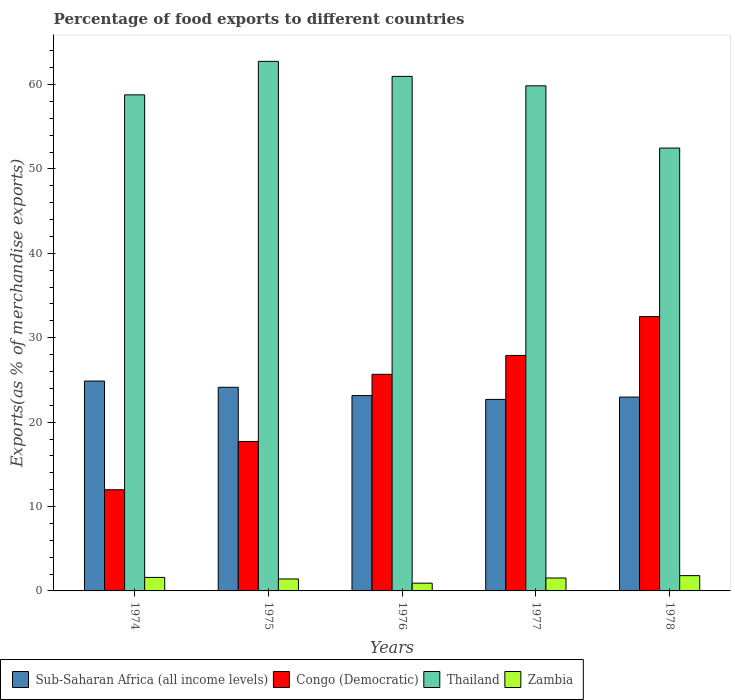How many different coloured bars are there?
Offer a terse response. 4. Are the number of bars per tick equal to the number of legend labels?
Your response must be concise. Yes. Are the number of bars on each tick of the X-axis equal?
Ensure brevity in your answer.  Yes. How many bars are there on the 4th tick from the left?
Keep it short and to the point. 4. How many bars are there on the 1st tick from the right?
Offer a very short reply. 4. In how many cases, is the number of bars for a given year not equal to the number of legend labels?
Ensure brevity in your answer.  0. What is the percentage of exports to different countries in Thailand in 1978?
Your answer should be compact. 52.47. Across all years, what is the maximum percentage of exports to different countries in Zambia?
Ensure brevity in your answer.  1.81. Across all years, what is the minimum percentage of exports to different countries in Thailand?
Ensure brevity in your answer.  52.47. In which year was the percentage of exports to different countries in Congo (Democratic) maximum?
Offer a very short reply. 1978. In which year was the percentage of exports to different countries in Sub-Saharan Africa (all income levels) minimum?
Give a very brief answer. 1977. What is the total percentage of exports to different countries in Thailand in the graph?
Provide a short and direct response. 294.83. What is the difference between the percentage of exports to different countries in Sub-Saharan Africa (all income levels) in 1976 and that in 1978?
Provide a short and direct response. 0.18. What is the difference between the percentage of exports to different countries in Sub-Saharan Africa (all income levels) in 1975 and the percentage of exports to different countries in Congo (Democratic) in 1978?
Offer a terse response. -8.38. What is the average percentage of exports to different countries in Zambia per year?
Your response must be concise. 1.46. In the year 1975, what is the difference between the percentage of exports to different countries in Sub-Saharan Africa (all income levels) and percentage of exports to different countries in Congo (Democratic)?
Give a very brief answer. 6.42. In how many years, is the percentage of exports to different countries in Sub-Saharan Africa (all income levels) greater than 48 %?
Your answer should be compact. 0. What is the ratio of the percentage of exports to different countries in Thailand in 1974 to that in 1976?
Your answer should be very brief. 0.96. Is the difference between the percentage of exports to different countries in Sub-Saharan Africa (all income levels) in 1977 and 1978 greater than the difference between the percentage of exports to different countries in Congo (Democratic) in 1977 and 1978?
Offer a terse response. Yes. What is the difference between the highest and the second highest percentage of exports to different countries in Congo (Democratic)?
Provide a short and direct response. 4.61. What is the difference between the highest and the lowest percentage of exports to different countries in Congo (Democratic)?
Offer a terse response. 20.52. Is the sum of the percentage of exports to different countries in Zambia in 1976 and 1978 greater than the maximum percentage of exports to different countries in Sub-Saharan Africa (all income levels) across all years?
Your answer should be compact. No. Is it the case that in every year, the sum of the percentage of exports to different countries in Zambia and percentage of exports to different countries in Thailand is greater than the sum of percentage of exports to different countries in Congo (Democratic) and percentage of exports to different countries in Sub-Saharan Africa (all income levels)?
Provide a succinct answer. No. What does the 3rd bar from the left in 1975 represents?
Your response must be concise. Thailand. What does the 3rd bar from the right in 1975 represents?
Provide a short and direct response. Congo (Democratic). Is it the case that in every year, the sum of the percentage of exports to different countries in Congo (Democratic) and percentage of exports to different countries in Zambia is greater than the percentage of exports to different countries in Sub-Saharan Africa (all income levels)?
Provide a succinct answer. No. How many years are there in the graph?
Give a very brief answer. 5. Are the values on the major ticks of Y-axis written in scientific E-notation?
Provide a succinct answer. No. How many legend labels are there?
Ensure brevity in your answer.  4. How are the legend labels stacked?
Offer a terse response. Horizontal. What is the title of the graph?
Ensure brevity in your answer.  Percentage of food exports to different countries. What is the label or title of the Y-axis?
Your answer should be compact. Exports(as % of merchandise exports). What is the Exports(as % of merchandise exports) in Sub-Saharan Africa (all income levels) in 1974?
Offer a very short reply. 24.87. What is the Exports(as % of merchandise exports) in Congo (Democratic) in 1974?
Offer a very short reply. 11.99. What is the Exports(as % of merchandise exports) in Thailand in 1974?
Provide a short and direct response. 58.78. What is the Exports(as % of merchandise exports) in Zambia in 1974?
Your answer should be very brief. 1.6. What is the Exports(as % of merchandise exports) in Sub-Saharan Africa (all income levels) in 1975?
Give a very brief answer. 24.13. What is the Exports(as % of merchandise exports) in Congo (Democratic) in 1975?
Keep it short and to the point. 17.71. What is the Exports(as % of merchandise exports) in Thailand in 1975?
Ensure brevity in your answer.  62.75. What is the Exports(as % of merchandise exports) in Zambia in 1975?
Give a very brief answer. 1.42. What is the Exports(as % of merchandise exports) of Sub-Saharan Africa (all income levels) in 1976?
Your response must be concise. 23.15. What is the Exports(as % of merchandise exports) of Congo (Democratic) in 1976?
Provide a succinct answer. 25.67. What is the Exports(as % of merchandise exports) in Thailand in 1976?
Offer a very short reply. 60.97. What is the Exports(as % of merchandise exports) in Zambia in 1976?
Your answer should be compact. 0.92. What is the Exports(as % of merchandise exports) of Sub-Saharan Africa (all income levels) in 1977?
Your response must be concise. 22.7. What is the Exports(as % of merchandise exports) in Congo (Democratic) in 1977?
Offer a terse response. 27.9. What is the Exports(as % of merchandise exports) of Thailand in 1977?
Provide a short and direct response. 59.85. What is the Exports(as % of merchandise exports) of Zambia in 1977?
Provide a succinct answer. 1.53. What is the Exports(as % of merchandise exports) in Sub-Saharan Africa (all income levels) in 1978?
Provide a short and direct response. 22.97. What is the Exports(as % of merchandise exports) of Congo (Democratic) in 1978?
Make the answer very short. 32.51. What is the Exports(as % of merchandise exports) of Thailand in 1978?
Offer a very short reply. 52.47. What is the Exports(as % of merchandise exports) of Zambia in 1978?
Provide a succinct answer. 1.81. Across all years, what is the maximum Exports(as % of merchandise exports) in Sub-Saharan Africa (all income levels)?
Offer a very short reply. 24.87. Across all years, what is the maximum Exports(as % of merchandise exports) of Congo (Democratic)?
Provide a succinct answer. 32.51. Across all years, what is the maximum Exports(as % of merchandise exports) in Thailand?
Offer a terse response. 62.75. Across all years, what is the maximum Exports(as % of merchandise exports) of Zambia?
Your answer should be compact. 1.81. Across all years, what is the minimum Exports(as % of merchandise exports) of Sub-Saharan Africa (all income levels)?
Offer a terse response. 22.7. Across all years, what is the minimum Exports(as % of merchandise exports) in Congo (Democratic)?
Give a very brief answer. 11.99. Across all years, what is the minimum Exports(as % of merchandise exports) of Thailand?
Provide a succinct answer. 52.47. Across all years, what is the minimum Exports(as % of merchandise exports) in Zambia?
Your response must be concise. 0.92. What is the total Exports(as % of merchandise exports) in Sub-Saharan Africa (all income levels) in the graph?
Offer a very short reply. 117.81. What is the total Exports(as % of merchandise exports) in Congo (Democratic) in the graph?
Your answer should be very brief. 115.77. What is the total Exports(as % of merchandise exports) of Thailand in the graph?
Offer a terse response. 294.83. What is the total Exports(as % of merchandise exports) in Zambia in the graph?
Your response must be concise. 7.28. What is the difference between the Exports(as % of merchandise exports) of Sub-Saharan Africa (all income levels) in 1974 and that in 1975?
Offer a terse response. 0.74. What is the difference between the Exports(as % of merchandise exports) in Congo (Democratic) in 1974 and that in 1975?
Offer a very short reply. -5.72. What is the difference between the Exports(as % of merchandise exports) in Thailand in 1974 and that in 1975?
Provide a short and direct response. -3.97. What is the difference between the Exports(as % of merchandise exports) of Zambia in 1974 and that in 1975?
Keep it short and to the point. 0.18. What is the difference between the Exports(as % of merchandise exports) in Sub-Saharan Africa (all income levels) in 1974 and that in 1976?
Provide a short and direct response. 1.72. What is the difference between the Exports(as % of merchandise exports) in Congo (Democratic) in 1974 and that in 1976?
Provide a succinct answer. -13.68. What is the difference between the Exports(as % of merchandise exports) in Thailand in 1974 and that in 1976?
Ensure brevity in your answer.  -2.19. What is the difference between the Exports(as % of merchandise exports) in Zambia in 1974 and that in 1976?
Provide a succinct answer. 0.68. What is the difference between the Exports(as % of merchandise exports) in Sub-Saharan Africa (all income levels) in 1974 and that in 1977?
Make the answer very short. 2.17. What is the difference between the Exports(as % of merchandise exports) of Congo (Democratic) in 1974 and that in 1977?
Provide a succinct answer. -15.91. What is the difference between the Exports(as % of merchandise exports) of Thailand in 1974 and that in 1977?
Your answer should be very brief. -1.07. What is the difference between the Exports(as % of merchandise exports) of Zambia in 1974 and that in 1977?
Keep it short and to the point. 0.07. What is the difference between the Exports(as % of merchandise exports) of Sub-Saharan Africa (all income levels) in 1974 and that in 1978?
Offer a very short reply. 1.9. What is the difference between the Exports(as % of merchandise exports) of Congo (Democratic) in 1974 and that in 1978?
Offer a very short reply. -20.52. What is the difference between the Exports(as % of merchandise exports) of Thailand in 1974 and that in 1978?
Make the answer very short. 6.31. What is the difference between the Exports(as % of merchandise exports) of Zambia in 1974 and that in 1978?
Offer a very short reply. -0.21. What is the difference between the Exports(as % of merchandise exports) of Sub-Saharan Africa (all income levels) in 1975 and that in 1976?
Your answer should be compact. 0.98. What is the difference between the Exports(as % of merchandise exports) in Congo (Democratic) in 1975 and that in 1976?
Provide a short and direct response. -7.96. What is the difference between the Exports(as % of merchandise exports) of Thailand in 1975 and that in 1976?
Your answer should be very brief. 1.78. What is the difference between the Exports(as % of merchandise exports) in Zambia in 1975 and that in 1976?
Give a very brief answer. 0.5. What is the difference between the Exports(as % of merchandise exports) of Sub-Saharan Africa (all income levels) in 1975 and that in 1977?
Provide a short and direct response. 1.43. What is the difference between the Exports(as % of merchandise exports) of Congo (Democratic) in 1975 and that in 1977?
Your answer should be very brief. -10.19. What is the difference between the Exports(as % of merchandise exports) in Thailand in 1975 and that in 1977?
Your answer should be compact. 2.9. What is the difference between the Exports(as % of merchandise exports) of Zambia in 1975 and that in 1977?
Keep it short and to the point. -0.11. What is the difference between the Exports(as % of merchandise exports) in Sub-Saharan Africa (all income levels) in 1975 and that in 1978?
Make the answer very short. 1.16. What is the difference between the Exports(as % of merchandise exports) in Congo (Democratic) in 1975 and that in 1978?
Ensure brevity in your answer.  -14.8. What is the difference between the Exports(as % of merchandise exports) of Thailand in 1975 and that in 1978?
Keep it short and to the point. 10.28. What is the difference between the Exports(as % of merchandise exports) of Zambia in 1975 and that in 1978?
Make the answer very short. -0.39. What is the difference between the Exports(as % of merchandise exports) of Sub-Saharan Africa (all income levels) in 1976 and that in 1977?
Your answer should be very brief. 0.45. What is the difference between the Exports(as % of merchandise exports) of Congo (Democratic) in 1976 and that in 1977?
Keep it short and to the point. -2.24. What is the difference between the Exports(as % of merchandise exports) in Thailand in 1976 and that in 1977?
Make the answer very short. 1.12. What is the difference between the Exports(as % of merchandise exports) of Zambia in 1976 and that in 1977?
Offer a terse response. -0.61. What is the difference between the Exports(as % of merchandise exports) of Sub-Saharan Africa (all income levels) in 1976 and that in 1978?
Make the answer very short. 0.18. What is the difference between the Exports(as % of merchandise exports) in Congo (Democratic) in 1976 and that in 1978?
Provide a succinct answer. -6.84. What is the difference between the Exports(as % of merchandise exports) of Thailand in 1976 and that in 1978?
Ensure brevity in your answer.  8.49. What is the difference between the Exports(as % of merchandise exports) of Zambia in 1976 and that in 1978?
Provide a succinct answer. -0.89. What is the difference between the Exports(as % of merchandise exports) in Sub-Saharan Africa (all income levels) in 1977 and that in 1978?
Make the answer very short. -0.27. What is the difference between the Exports(as % of merchandise exports) in Congo (Democratic) in 1977 and that in 1978?
Ensure brevity in your answer.  -4.61. What is the difference between the Exports(as % of merchandise exports) of Thailand in 1977 and that in 1978?
Keep it short and to the point. 7.38. What is the difference between the Exports(as % of merchandise exports) of Zambia in 1977 and that in 1978?
Keep it short and to the point. -0.28. What is the difference between the Exports(as % of merchandise exports) in Sub-Saharan Africa (all income levels) in 1974 and the Exports(as % of merchandise exports) in Congo (Democratic) in 1975?
Your answer should be very brief. 7.16. What is the difference between the Exports(as % of merchandise exports) in Sub-Saharan Africa (all income levels) in 1974 and the Exports(as % of merchandise exports) in Thailand in 1975?
Offer a terse response. -37.88. What is the difference between the Exports(as % of merchandise exports) in Sub-Saharan Africa (all income levels) in 1974 and the Exports(as % of merchandise exports) in Zambia in 1975?
Offer a very short reply. 23.45. What is the difference between the Exports(as % of merchandise exports) in Congo (Democratic) in 1974 and the Exports(as % of merchandise exports) in Thailand in 1975?
Offer a very short reply. -50.76. What is the difference between the Exports(as % of merchandise exports) of Congo (Democratic) in 1974 and the Exports(as % of merchandise exports) of Zambia in 1975?
Make the answer very short. 10.57. What is the difference between the Exports(as % of merchandise exports) in Thailand in 1974 and the Exports(as % of merchandise exports) in Zambia in 1975?
Ensure brevity in your answer.  57.36. What is the difference between the Exports(as % of merchandise exports) of Sub-Saharan Africa (all income levels) in 1974 and the Exports(as % of merchandise exports) of Congo (Democratic) in 1976?
Offer a very short reply. -0.8. What is the difference between the Exports(as % of merchandise exports) in Sub-Saharan Africa (all income levels) in 1974 and the Exports(as % of merchandise exports) in Thailand in 1976?
Keep it short and to the point. -36.1. What is the difference between the Exports(as % of merchandise exports) in Sub-Saharan Africa (all income levels) in 1974 and the Exports(as % of merchandise exports) in Zambia in 1976?
Offer a terse response. 23.95. What is the difference between the Exports(as % of merchandise exports) of Congo (Democratic) in 1974 and the Exports(as % of merchandise exports) of Thailand in 1976?
Provide a short and direct response. -48.98. What is the difference between the Exports(as % of merchandise exports) of Congo (Democratic) in 1974 and the Exports(as % of merchandise exports) of Zambia in 1976?
Your answer should be compact. 11.07. What is the difference between the Exports(as % of merchandise exports) in Thailand in 1974 and the Exports(as % of merchandise exports) in Zambia in 1976?
Ensure brevity in your answer.  57.86. What is the difference between the Exports(as % of merchandise exports) of Sub-Saharan Africa (all income levels) in 1974 and the Exports(as % of merchandise exports) of Congo (Democratic) in 1977?
Your answer should be compact. -3.03. What is the difference between the Exports(as % of merchandise exports) in Sub-Saharan Africa (all income levels) in 1974 and the Exports(as % of merchandise exports) in Thailand in 1977?
Give a very brief answer. -34.98. What is the difference between the Exports(as % of merchandise exports) in Sub-Saharan Africa (all income levels) in 1974 and the Exports(as % of merchandise exports) in Zambia in 1977?
Provide a short and direct response. 23.34. What is the difference between the Exports(as % of merchandise exports) in Congo (Democratic) in 1974 and the Exports(as % of merchandise exports) in Thailand in 1977?
Provide a short and direct response. -47.86. What is the difference between the Exports(as % of merchandise exports) of Congo (Democratic) in 1974 and the Exports(as % of merchandise exports) of Zambia in 1977?
Give a very brief answer. 10.46. What is the difference between the Exports(as % of merchandise exports) in Thailand in 1974 and the Exports(as % of merchandise exports) in Zambia in 1977?
Make the answer very short. 57.25. What is the difference between the Exports(as % of merchandise exports) of Sub-Saharan Africa (all income levels) in 1974 and the Exports(as % of merchandise exports) of Congo (Democratic) in 1978?
Offer a terse response. -7.64. What is the difference between the Exports(as % of merchandise exports) in Sub-Saharan Africa (all income levels) in 1974 and the Exports(as % of merchandise exports) in Thailand in 1978?
Your response must be concise. -27.61. What is the difference between the Exports(as % of merchandise exports) in Sub-Saharan Africa (all income levels) in 1974 and the Exports(as % of merchandise exports) in Zambia in 1978?
Offer a very short reply. 23.06. What is the difference between the Exports(as % of merchandise exports) in Congo (Democratic) in 1974 and the Exports(as % of merchandise exports) in Thailand in 1978?
Provide a succinct answer. -40.49. What is the difference between the Exports(as % of merchandise exports) in Congo (Democratic) in 1974 and the Exports(as % of merchandise exports) in Zambia in 1978?
Give a very brief answer. 10.18. What is the difference between the Exports(as % of merchandise exports) in Thailand in 1974 and the Exports(as % of merchandise exports) in Zambia in 1978?
Your response must be concise. 56.97. What is the difference between the Exports(as % of merchandise exports) in Sub-Saharan Africa (all income levels) in 1975 and the Exports(as % of merchandise exports) in Congo (Democratic) in 1976?
Make the answer very short. -1.54. What is the difference between the Exports(as % of merchandise exports) of Sub-Saharan Africa (all income levels) in 1975 and the Exports(as % of merchandise exports) of Thailand in 1976?
Provide a short and direct response. -36.84. What is the difference between the Exports(as % of merchandise exports) in Sub-Saharan Africa (all income levels) in 1975 and the Exports(as % of merchandise exports) in Zambia in 1976?
Your answer should be compact. 23.21. What is the difference between the Exports(as % of merchandise exports) in Congo (Democratic) in 1975 and the Exports(as % of merchandise exports) in Thailand in 1976?
Give a very brief answer. -43.26. What is the difference between the Exports(as % of merchandise exports) in Congo (Democratic) in 1975 and the Exports(as % of merchandise exports) in Zambia in 1976?
Your response must be concise. 16.79. What is the difference between the Exports(as % of merchandise exports) of Thailand in 1975 and the Exports(as % of merchandise exports) of Zambia in 1976?
Provide a short and direct response. 61.83. What is the difference between the Exports(as % of merchandise exports) in Sub-Saharan Africa (all income levels) in 1975 and the Exports(as % of merchandise exports) in Congo (Democratic) in 1977?
Offer a terse response. -3.77. What is the difference between the Exports(as % of merchandise exports) of Sub-Saharan Africa (all income levels) in 1975 and the Exports(as % of merchandise exports) of Thailand in 1977?
Make the answer very short. -35.72. What is the difference between the Exports(as % of merchandise exports) of Sub-Saharan Africa (all income levels) in 1975 and the Exports(as % of merchandise exports) of Zambia in 1977?
Provide a short and direct response. 22.6. What is the difference between the Exports(as % of merchandise exports) in Congo (Democratic) in 1975 and the Exports(as % of merchandise exports) in Thailand in 1977?
Offer a very short reply. -42.14. What is the difference between the Exports(as % of merchandise exports) of Congo (Democratic) in 1975 and the Exports(as % of merchandise exports) of Zambia in 1977?
Your answer should be very brief. 16.18. What is the difference between the Exports(as % of merchandise exports) of Thailand in 1975 and the Exports(as % of merchandise exports) of Zambia in 1977?
Make the answer very short. 61.22. What is the difference between the Exports(as % of merchandise exports) in Sub-Saharan Africa (all income levels) in 1975 and the Exports(as % of merchandise exports) in Congo (Democratic) in 1978?
Provide a short and direct response. -8.38. What is the difference between the Exports(as % of merchandise exports) of Sub-Saharan Africa (all income levels) in 1975 and the Exports(as % of merchandise exports) of Thailand in 1978?
Ensure brevity in your answer.  -28.35. What is the difference between the Exports(as % of merchandise exports) of Sub-Saharan Africa (all income levels) in 1975 and the Exports(as % of merchandise exports) of Zambia in 1978?
Your answer should be compact. 22.32. What is the difference between the Exports(as % of merchandise exports) in Congo (Democratic) in 1975 and the Exports(as % of merchandise exports) in Thailand in 1978?
Keep it short and to the point. -34.77. What is the difference between the Exports(as % of merchandise exports) in Congo (Democratic) in 1975 and the Exports(as % of merchandise exports) in Zambia in 1978?
Your response must be concise. 15.9. What is the difference between the Exports(as % of merchandise exports) in Thailand in 1975 and the Exports(as % of merchandise exports) in Zambia in 1978?
Your response must be concise. 60.94. What is the difference between the Exports(as % of merchandise exports) in Sub-Saharan Africa (all income levels) in 1976 and the Exports(as % of merchandise exports) in Congo (Democratic) in 1977?
Your answer should be very brief. -4.76. What is the difference between the Exports(as % of merchandise exports) in Sub-Saharan Africa (all income levels) in 1976 and the Exports(as % of merchandise exports) in Thailand in 1977?
Your answer should be compact. -36.7. What is the difference between the Exports(as % of merchandise exports) of Sub-Saharan Africa (all income levels) in 1976 and the Exports(as % of merchandise exports) of Zambia in 1977?
Provide a short and direct response. 21.61. What is the difference between the Exports(as % of merchandise exports) in Congo (Democratic) in 1976 and the Exports(as % of merchandise exports) in Thailand in 1977?
Provide a short and direct response. -34.18. What is the difference between the Exports(as % of merchandise exports) in Congo (Democratic) in 1976 and the Exports(as % of merchandise exports) in Zambia in 1977?
Your answer should be compact. 24.14. What is the difference between the Exports(as % of merchandise exports) of Thailand in 1976 and the Exports(as % of merchandise exports) of Zambia in 1977?
Your response must be concise. 59.44. What is the difference between the Exports(as % of merchandise exports) of Sub-Saharan Africa (all income levels) in 1976 and the Exports(as % of merchandise exports) of Congo (Democratic) in 1978?
Ensure brevity in your answer.  -9.36. What is the difference between the Exports(as % of merchandise exports) in Sub-Saharan Africa (all income levels) in 1976 and the Exports(as % of merchandise exports) in Thailand in 1978?
Your answer should be compact. -29.33. What is the difference between the Exports(as % of merchandise exports) in Sub-Saharan Africa (all income levels) in 1976 and the Exports(as % of merchandise exports) in Zambia in 1978?
Offer a very short reply. 21.33. What is the difference between the Exports(as % of merchandise exports) of Congo (Democratic) in 1976 and the Exports(as % of merchandise exports) of Thailand in 1978?
Your answer should be compact. -26.81. What is the difference between the Exports(as % of merchandise exports) of Congo (Democratic) in 1976 and the Exports(as % of merchandise exports) of Zambia in 1978?
Make the answer very short. 23.85. What is the difference between the Exports(as % of merchandise exports) of Thailand in 1976 and the Exports(as % of merchandise exports) of Zambia in 1978?
Provide a succinct answer. 59.16. What is the difference between the Exports(as % of merchandise exports) in Sub-Saharan Africa (all income levels) in 1977 and the Exports(as % of merchandise exports) in Congo (Democratic) in 1978?
Offer a very short reply. -9.81. What is the difference between the Exports(as % of merchandise exports) in Sub-Saharan Africa (all income levels) in 1977 and the Exports(as % of merchandise exports) in Thailand in 1978?
Your answer should be very brief. -29.78. What is the difference between the Exports(as % of merchandise exports) in Sub-Saharan Africa (all income levels) in 1977 and the Exports(as % of merchandise exports) in Zambia in 1978?
Your answer should be very brief. 20.88. What is the difference between the Exports(as % of merchandise exports) of Congo (Democratic) in 1977 and the Exports(as % of merchandise exports) of Thailand in 1978?
Make the answer very short. -24.57. What is the difference between the Exports(as % of merchandise exports) of Congo (Democratic) in 1977 and the Exports(as % of merchandise exports) of Zambia in 1978?
Your answer should be compact. 26.09. What is the difference between the Exports(as % of merchandise exports) of Thailand in 1977 and the Exports(as % of merchandise exports) of Zambia in 1978?
Ensure brevity in your answer.  58.04. What is the average Exports(as % of merchandise exports) in Sub-Saharan Africa (all income levels) per year?
Your response must be concise. 23.56. What is the average Exports(as % of merchandise exports) in Congo (Democratic) per year?
Keep it short and to the point. 23.15. What is the average Exports(as % of merchandise exports) in Thailand per year?
Your answer should be very brief. 58.97. What is the average Exports(as % of merchandise exports) of Zambia per year?
Your response must be concise. 1.46. In the year 1974, what is the difference between the Exports(as % of merchandise exports) in Sub-Saharan Africa (all income levels) and Exports(as % of merchandise exports) in Congo (Democratic)?
Ensure brevity in your answer.  12.88. In the year 1974, what is the difference between the Exports(as % of merchandise exports) in Sub-Saharan Africa (all income levels) and Exports(as % of merchandise exports) in Thailand?
Your answer should be compact. -33.91. In the year 1974, what is the difference between the Exports(as % of merchandise exports) in Sub-Saharan Africa (all income levels) and Exports(as % of merchandise exports) in Zambia?
Your answer should be very brief. 23.27. In the year 1974, what is the difference between the Exports(as % of merchandise exports) in Congo (Democratic) and Exports(as % of merchandise exports) in Thailand?
Provide a succinct answer. -46.79. In the year 1974, what is the difference between the Exports(as % of merchandise exports) in Congo (Democratic) and Exports(as % of merchandise exports) in Zambia?
Your response must be concise. 10.39. In the year 1974, what is the difference between the Exports(as % of merchandise exports) in Thailand and Exports(as % of merchandise exports) in Zambia?
Your response must be concise. 57.18. In the year 1975, what is the difference between the Exports(as % of merchandise exports) of Sub-Saharan Africa (all income levels) and Exports(as % of merchandise exports) of Congo (Democratic)?
Provide a short and direct response. 6.42. In the year 1975, what is the difference between the Exports(as % of merchandise exports) of Sub-Saharan Africa (all income levels) and Exports(as % of merchandise exports) of Thailand?
Make the answer very short. -38.62. In the year 1975, what is the difference between the Exports(as % of merchandise exports) of Sub-Saharan Africa (all income levels) and Exports(as % of merchandise exports) of Zambia?
Make the answer very short. 22.71. In the year 1975, what is the difference between the Exports(as % of merchandise exports) of Congo (Democratic) and Exports(as % of merchandise exports) of Thailand?
Your answer should be very brief. -45.04. In the year 1975, what is the difference between the Exports(as % of merchandise exports) of Congo (Democratic) and Exports(as % of merchandise exports) of Zambia?
Offer a very short reply. 16.29. In the year 1975, what is the difference between the Exports(as % of merchandise exports) in Thailand and Exports(as % of merchandise exports) in Zambia?
Give a very brief answer. 61.33. In the year 1976, what is the difference between the Exports(as % of merchandise exports) in Sub-Saharan Africa (all income levels) and Exports(as % of merchandise exports) in Congo (Democratic)?
Your answer should be very brief. -2.52. In the year 1976, what is the difference between the Exports(as % of merchandise exports) of Sub-Saharan Africa (all income levels) and Exports(as % of merchandise exports) of Thailand?
Provide a short and direct response. -37.82. In the year 1976, what is the difference between the Exports(as % of merchandise exports) of Sub-Saharan Africa (all income levels) and Exports(as % of merchandise exports) of Zambia?
Your answer should be compact. 22.23. In the year 1976, what is the difference between the Exports(as % of merchandise exports) of Congo (Democratic) and Exports(as % of merchandise exports) of Thailand?
Ensure brevity in your answer.  -35.3. In the year 1976, what is the difference between the Exports(as % of merchandise exports) of Congo (Democratic) and Exports(as % of merchandise exports) of Zambia?
Ensure brevity in your answer.  24.75. In the year 1976, what is the difference between the Exports(as % of merchandise exports) of Thailand and Exports(as % of merchandise exports) of Zambia?
Offer a very short reply. 60.05. In the year 1977, what is the difference between the Exports(as % of merchandise exports) in Sub-Saharan Africa (all income levels) and Exports(as % of merchandise exports) in Congo (Democratic)?
Give a very brief answer. -5.21. In the year 1977, what is the difference between the Exports(as % of merchandise exports) in Sub-Saharan Africa (all income levels) and Exports(as % of merchandise exports) in Thailand?
Offer a very short reply. -37.16. In the year 1977, what is the difference between the Exports(as % of merchandise exports) of Sub-Saharan Africa (all income levels) and Exports(as % of merchandise exports) of Zambia?
Keep it short and to the point. 21.16. In the year 1977, what is the difference between the Exports(as % of merchandise exports) in Congo (Democratic) and Exports(as % of merchandise exports) in Thailand?
Your answer should be very brief. -31.95. In the year 1977, what is the difference between the Exports(as % of merchandise exports) of Congo (Democratic) and Exports(as % of merchandise exports) of Zambia?
Provide a short and direct response. 26.37. In the year 1977, what is the difference between the Exports(as % of merchandise exports) in Thailand and Exports(as % of merchandise exports) in Zambia?
Give a very brief answer. 58.32. In the year 1978, what is the difference between the Exports(as % of merchandise exports) of Sub-Saharan Africa (all income levels) and Exports(as % of merchandise exports) of Congo (Democratic)?
Make the answer very short. -9.54. In the year 1978, what is the difference between the Exports(as % of merchandise exports) in Sub-Saharan Africa (all income levels) and Exports(as % of merchandise exports) in Thailand?
Your response must be concise. -29.51. In the year 1978, what is the difference between the Exports(as % of merchandise exports) of Sub-Saharan Africa (all income levels) and Exports(as % of merchandise exports) of Zambia?
Offer a terse response. 21.16. In the year 1978, what is the difference between the Exports(as % of merchandise exports) in Congo (Democratic) and Exports(as % of merchandise exports) in Thailand?
Provide a short and direct response. -19.97. In the year 1978, what is the difference between the Exports(as % of merchandise exports) in Congo (Democratic) and Exports(as % of merchandise exports) in Zambia?
Your answer should be very brief. 30.7. In the year 1978, what is the difference between the Exports(as % of merchandise exports) of Thailand and Exports(as % of merchandise exports) of Zambia?
Your answer should be compact. 50.66. What is the ratio of the Exports(as % of merchandise exports) of Sub-Saharan Africa (all income levels) in 1974 to that in 1975?
Provide a short and direct response. 1.03. What is the ratio of the Exports(as % of merchandise exports) in Congo (Democratic) in 1974 to that in 1975?
Keep it short and to the point. 0.68. What is the ratio of the Exports(as % of merchandise exports) of Thailand in 1974 to that in 1975?
Offer a very short reply. 0.94. What is the ratio of the Exports(as % of merchandise exports) in Zambia in 1974 to that in 1975?
Your answer should be compact. 1.13. What is the ratio of the Exports(as % of merchandise exports) of Sub-Saharan Africa (all income levels) in 1974 to that in 1976?
Provide a short and direct response. 1.07. What is the ratio of the Exports(as % of merchandise exports) in Congo (Democratic) in 1974 to that in 1976?
Offer a terse response. 0.47. What is the ratio of the Exports(as % of merchandise exports) of Thailand in 1974 to that in 1976?
Give a very brief answer. 0.96. What is the ratio of the Exports(as % of merchandise exports) in Zambia in 1974 to that in 1976?
Provide a short and direct response. 1.74. What is the ratio of the Exports(as % of merchandise exports) in Sub-Saharan Africa (all income levels) in 1974 to that in 1977?
Make the answer very short. 1.1. What is the ratio of the Exports(as % of merchandise exports) of Congo (Democratic) in 1974 to that in 1977?
Offer a terse response. 0.43. What is the ratio of the Exports(as % of merchandise exports) in Thailand in 1974 to that in 1977?
Provide a succinct answer. 0.98. What is the ratio of the Exports(as % of merchandise exports) in Zambia in 1974 to that in 1977?
Give a very brief answer. 1.05. What is the ratio of the Exports(as % of merchandise exports) of Sub-Saharan Africa (all income levels) in 1974 to that in 1978?
Give a very brief answer. 1.08. What is the ratio of the Exports(as % of merchandise exports) of Congo (Democratic) in 1974 to that in 1978?
Offer a terse response. 0.37. What is the ratio of the Exports(as % of merchandise exports) in Thailand in 1974 to that in 1978?
Keep it short and to the point. 1.12. What is the ratio of the Exports(as % of merchandise exports) of Zambia in 1974 to that in 1978?
Keep it short and to the point. 0.88. What is the ratio of the Exports(as % of merchandise exports) of Sub-Saharan Africa (all income levels) in 1975 to that in 1976?
Your response must be concise. 1.04. What is the ratio of the Exports(as % of merchandise exports) in Congo (Democratic) in 1975 to that in 1976?
Your answer should be compact. 0.69. What is the ratio of the Exports(as % of merchandise exports) of Thailand in 1975 to that in 1976?
Provide a short and direct response. 1.03. What is the ratio of the Exports(as % of merchandise exports) in Zambia in 1975 to that in 1976?
Make the answer very short. 1.54. What is the ratio of the Exports(as % of merchandise exports) in Sub-Saharan Africa (all income levels) in 1975 to that in 1977?
Provide a short and direct response. 1.06. What is the ratio of the Exports(as % of merchandise exports) in Congo (Democratic) in 1975 to that in 1977?
Make the answer very short. 0.63. What is the ratio of the Exports(as % of merchandise exports) in Thailand in 1975 to that in 1977?
Your response must be concise. 1.05. What is the ratio of the Exports(as % of merchandise exports) of Zambia in 1975 to that in 1977?
Your answer should be compact. 0.93. What is the ratio of the Exports(as % of merchandise exports) in Sub-Saharan Africa (all income levels) in 1975 to that in 1978?
Provide a short and direct response. 1.05. What is the ratio of the Exports(as % of merchandise exports) in Congo (Democratic) in 1975 to that in 1978?
Make the answer very short. 0.54. What is the ratio of the Exports(as % of merchandise exports) of Thailand in 1975 to that in 1978?
Offer a terse response. 1.2. What is the ratio of the Exports(as % of merchandise exports) in Zambia in 1975 to that in 1978?
Provide a succinct answer. 0.78. What is the ratio of the Exports(as % of merchandise exports) of Sub-Saharan Africa (all income levels) in 1976 to that in 1977?
Provide a succinct answer. 1.02. What is the ratio of the Exports(as % of merchandise exports) of Congo (Democratic) in 1976 to that in 1977?
Make the answer very short. 0.92. What is the ratio of the Exports(as % of merchandise exports) in Thailand in 1976 to that in 1977?
Keep it short and to the point. 1.02. What is the ratio of the Exports(as % of merchandise exports) in Zambia in 1976 to that in 1977?
Ensure brevity in your answer.  0.6. What is the ratio of the Exports(as % of merchandise exports) in Sub-Saharan Africa (all income levels) in 1976 to that in 1978?
Offer a very short reply. 1.01. What is the ratio of the Exports(as % of merchandise exports) of Congo (Democratic) in 1976 to that in 1978?
Make the answer very short. 0.79. What is the ratio of the Exports(as % of merchandise exports) in Thailand in 1976 to that in 1978?
Ensure brevity in your answer.  1.16. What is the ratio of the Exports(as % of merchandise exports) of Zambia in 1976 to that in 1978?
Ensure brevity in your answer.  0.51. What is the ratio of the Exports(as % of merchandise exports) of Congo (Democratic) in 1977 to that in 1978?
Your answer should be compact. 0.86. What is the ratio of the Exports(as % of merchandise exports) in Thailand in 1977 to that in 1978?
Provide a short and direct response. 1.14. What is the ratio of the Exports(as % of merchandise exports) in Zambia in 1977 to that in 1978?
Make the answer very short. 0.85. What is the difference between the highest and the second highest Exports(as % of merchandise exports) of Sub-Saharan Africa (all income levels)?
Provide a short and direct response. 0.74. What is the difference between the highest and the second highest Exports(as % of merchandise exports) of Congo (Democratic)?
Make the answer very short. 4.61. What is the difference between the highest and the second highest Exports(as % of merchandise exports) of Thailand?
Give a very brief answer. 1.78. What is the difference between the highest and the second highest Exports(as % of merchandise exports) of Zambia?
Your answer should be very brief. 0.21. What is the difference between the highest and the lowest Exports(as % of merchandise exports) in Sub-Saharan Africa (all income levels)?
Your answer should be very brief. 2.17. What is the difference between the highest and the lowest Exports(as % of merchandise exports) of Congo (Democratic)?
Your answer should be very brief. 20.52. What is the difference between the highest and the lowest Exports(as % of merchandise exports) of Thailand?
Your response must be concise. 10.28. What is the difference between the highest and the lowest Exports(as % of merchandise exports) of Zambia?
Give a very brief answer. 0.89. 